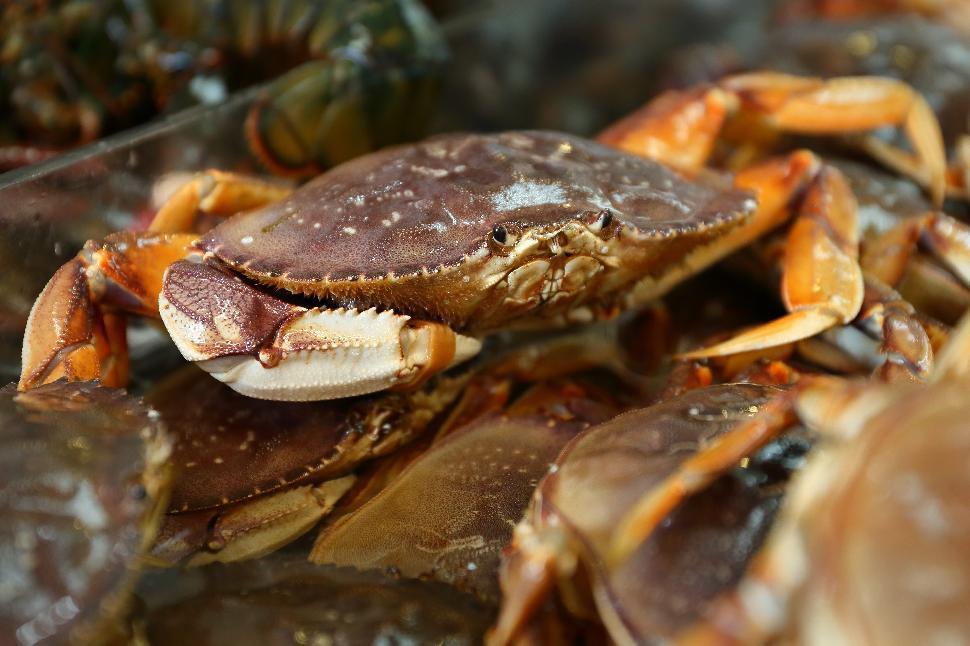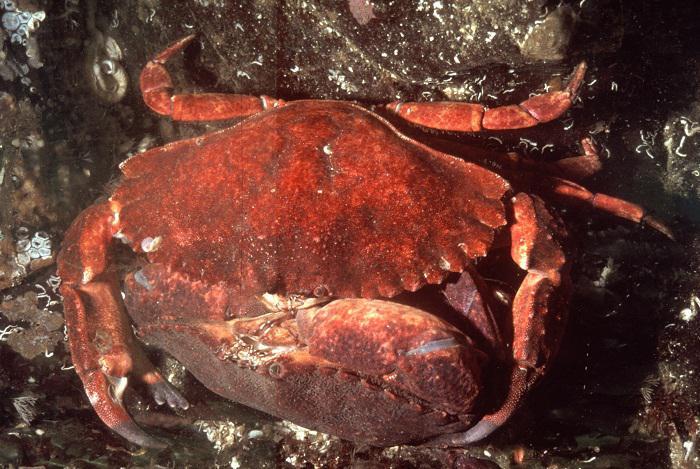The first image is the image on the left, the second image is the image on the right. Given the left and right images, does the statement "Each image shows an angled, forward-facing crab that is not held by a person, but the crab on the left is reddish-purple, and the crab on the right is not." hold true? Answer yes or no. No. The first image is the image on the left, the second image is the image on the right. Assess this claim about the two images: "In the image to the right, some of the crab's legs are red.". Correct or not? Answer yes or no. Yes. 